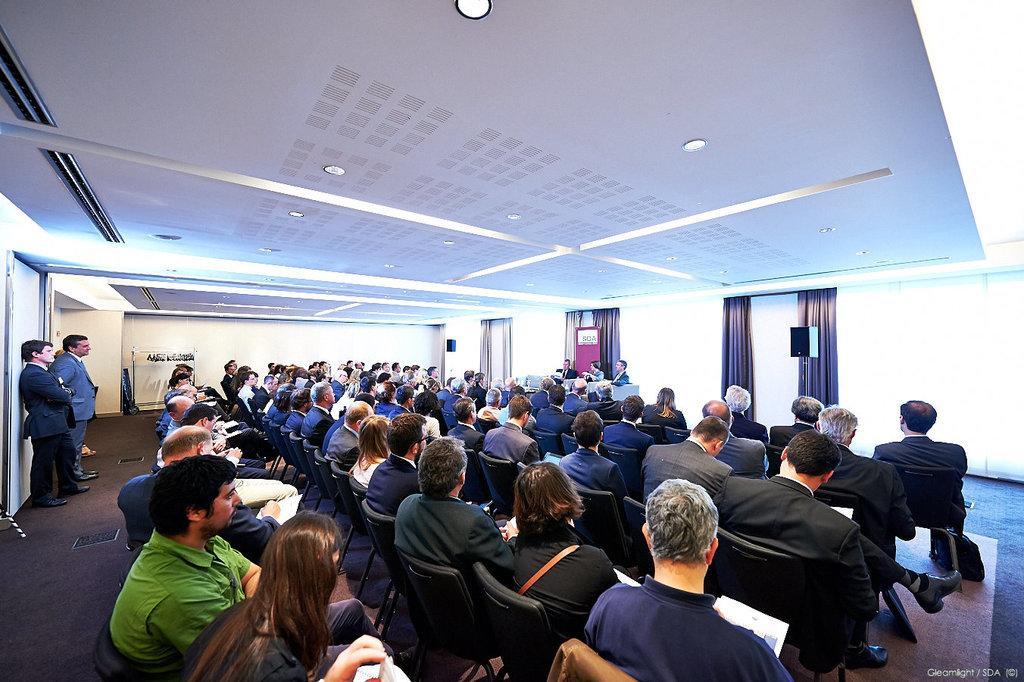Can you describe this image briefly? In this image we can see a few people, some of them are sitting on the chairs, some people are holding papers, there are lights, curtains, a table, also we can see the walls. 